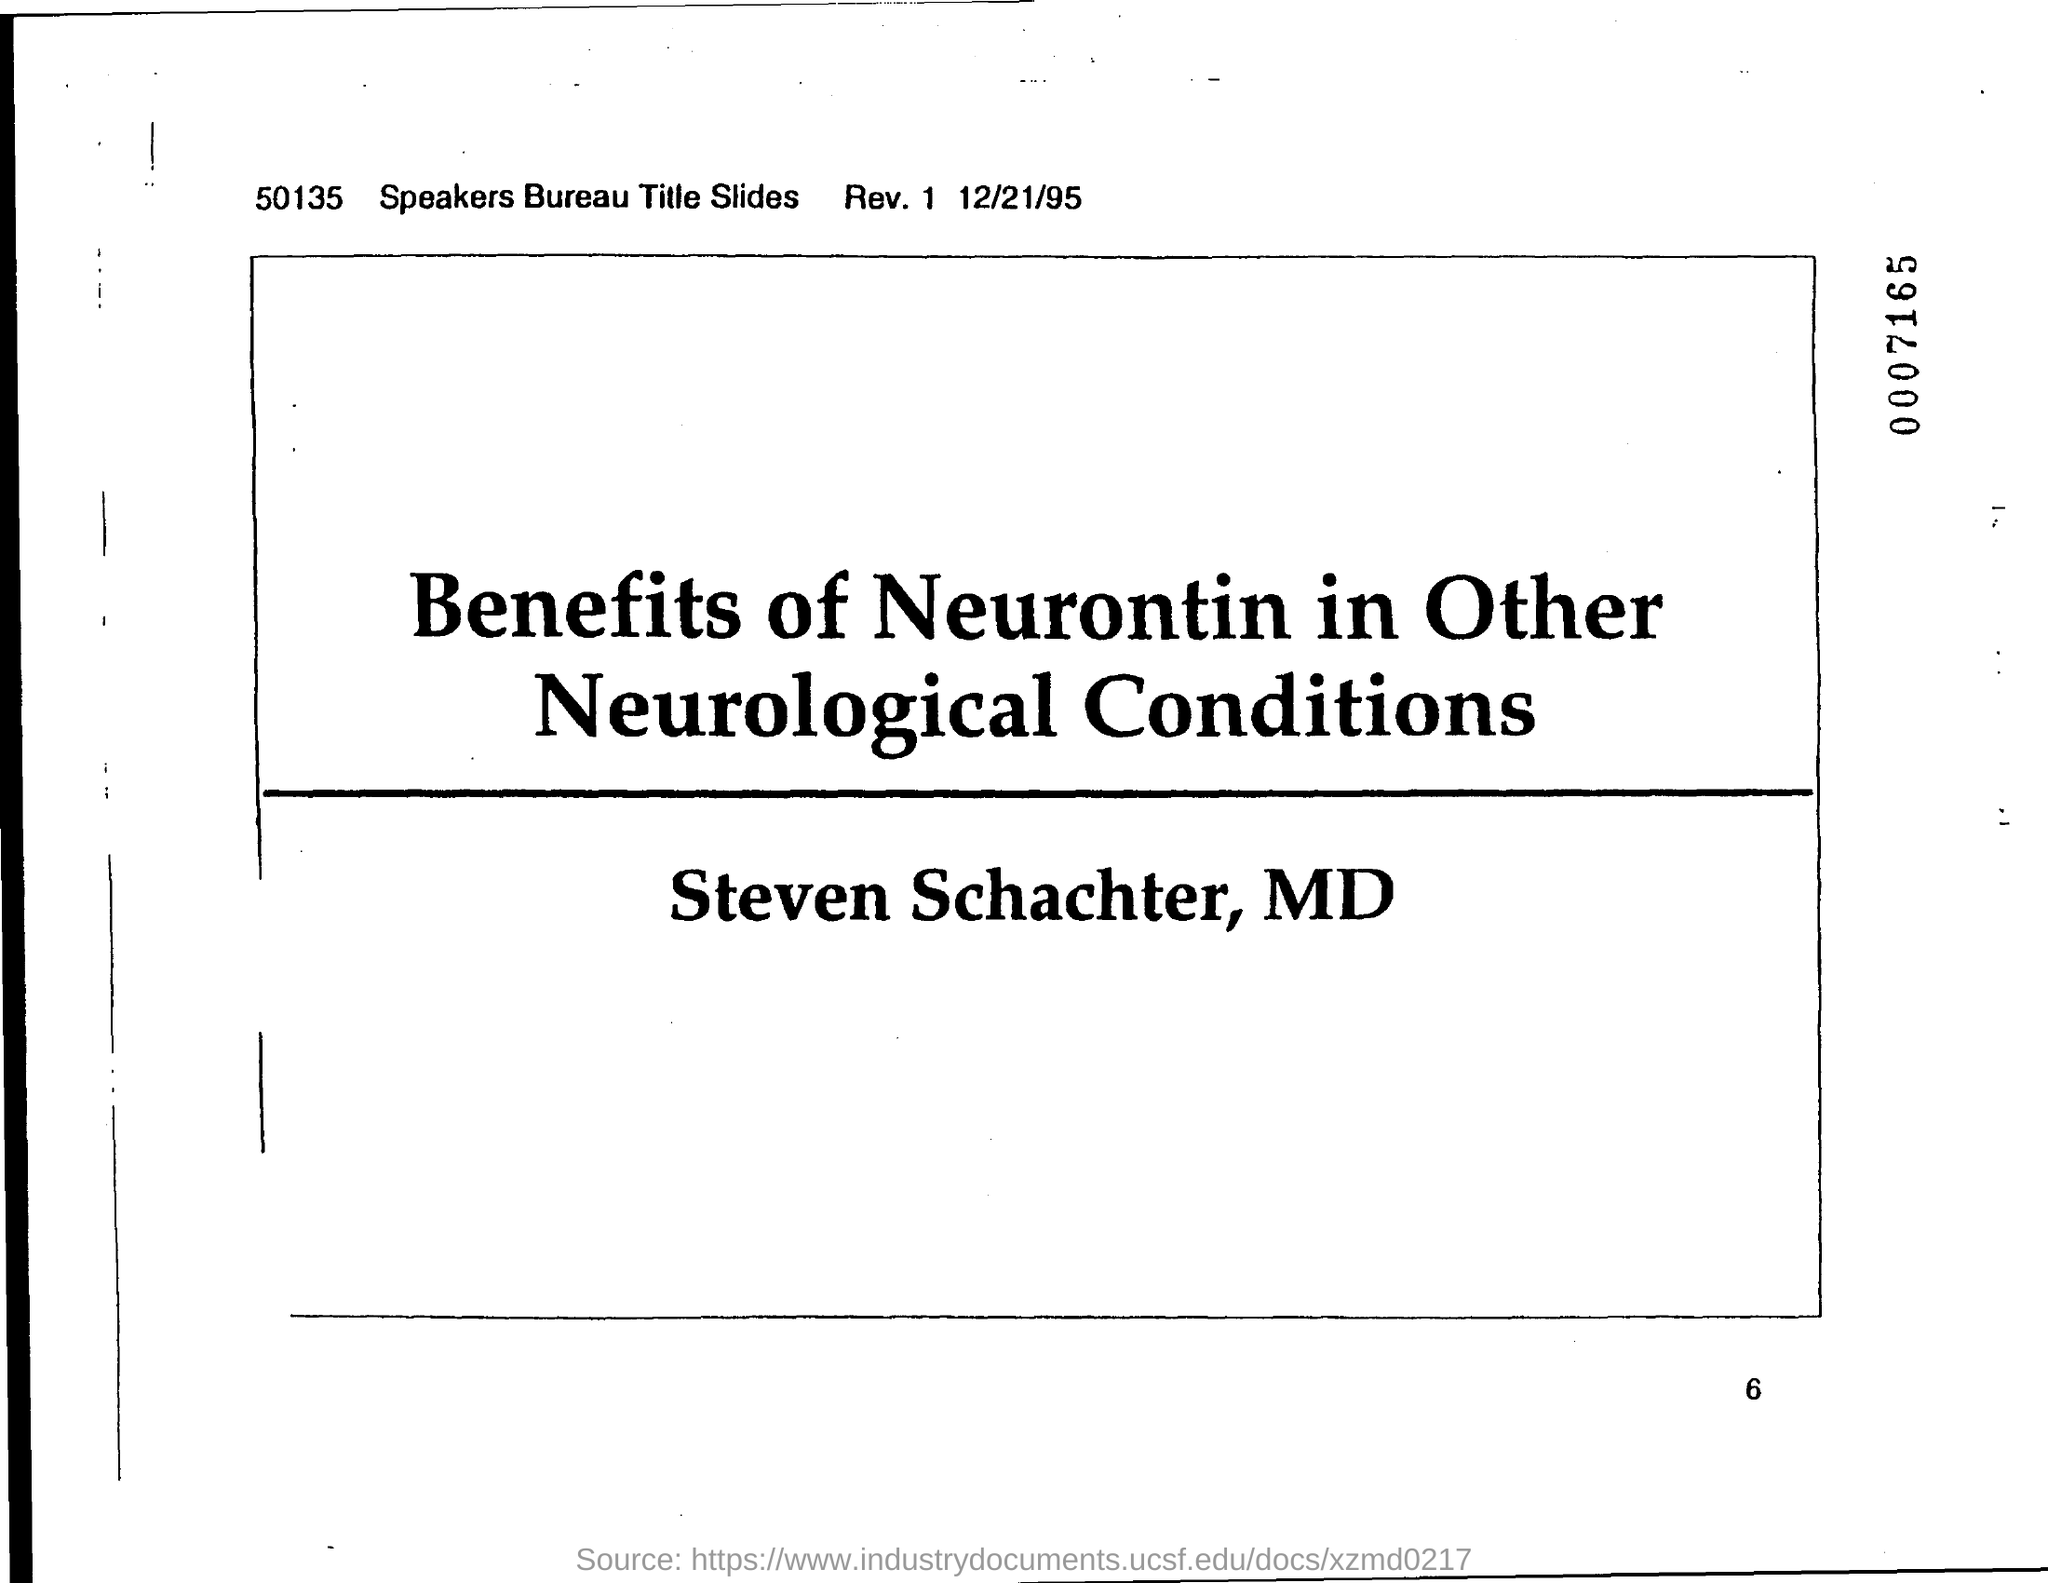What is the date on the document?
Offer a terse response. 12/21/95. 